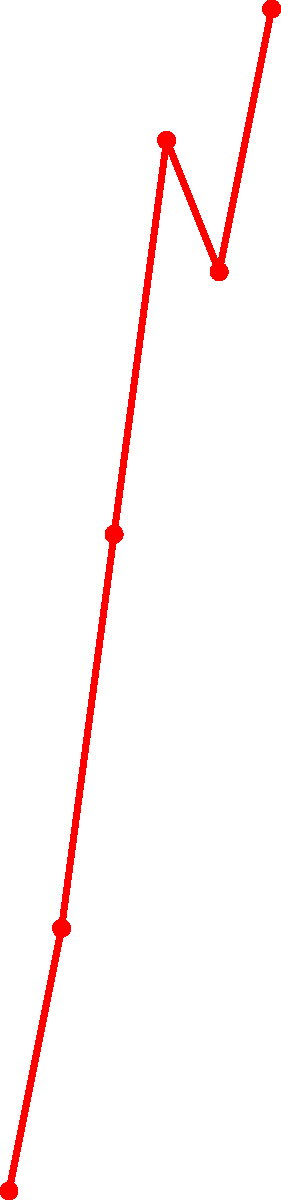Based on the timeline showing the impact of art exhibitions on international relations, which year marked a significant improvement in relations, and what event likely contributed to this positive change? To answer this question, we need to analyze the graph and identify key points:

1. The graph shows the International Relations Index from 2010 to 2020.
2. There's a steady increase in the index from 2010 to 2016.
3. A notable jump occurs between 2012 and 2014, with the index rising from 60 to 75.
4. The graph labels an "Art Exhibition" event at the 2014 data point.
5. After 2014, the index continues to rise, reaching 90 in 2016.
6. There's a slight dip in 2018, followed by another increase to 95 in 2020.

The most significant improvement in relations occurred in 2014, coinciding with the "Art Exhibition" event. This suggests that the art exhibition likely played a crucial role in enhancing international relations.

As a president recognizing the power of cultural diplomacy, you would identify this as a key moment where art and culture positively influenced diplomatic ties.
Answer: 2014; Art Exhibition 